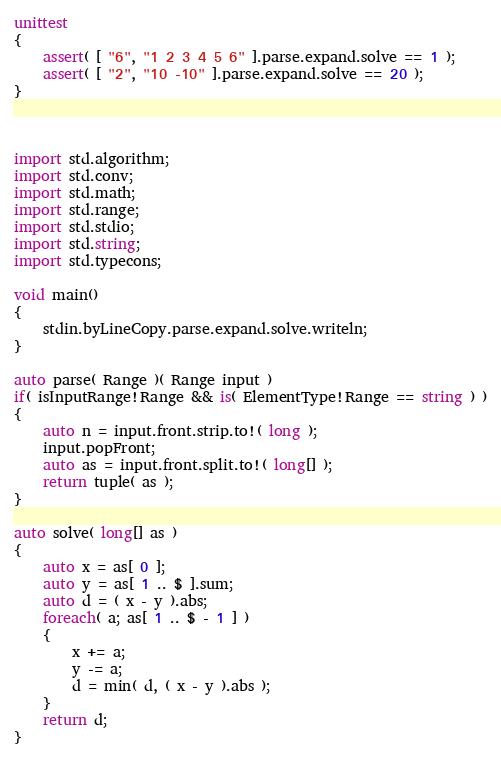Convert code to text. <code><loc_0><loc_0><loc_500><loc_500><_D_>unittest
{
	assert( [ "6", "1 2 3 4 5 6" ].parse.expand.solve == 1 );
	assert( [ "2", "10 -10" ].parse.expand.solve == 20 );
}



import std.algorithm;
import std.conv;
import std.math;
import std.range;
import std.stdio;
import std.string;
import std.typecons;

void main()
{
	stdin.byLineCopy.parse.expand.solve.writeln;
}

auto parse( Range )( Range input )
if( isInputRange!Range && is( ElementType!Range == string ) )
{
	auto n = input.front.strip.to!( long );
	input.popFront;
	auto as = input.front.split.to!( long[] );
	return tuple( as );
}

auto solve( long[] as )
{
	auto x = as[ 0 ];
	auto y = as[ 1 .. $ ].sum;
	auto d = ( x - y ).abs;
	foreach( a; as[ 1 .. $ - 1 ] )
	{
		x += a;
		y -= a;
		d = min( d, ( x - y ).abs );
	}
	return d;
}
</code> 